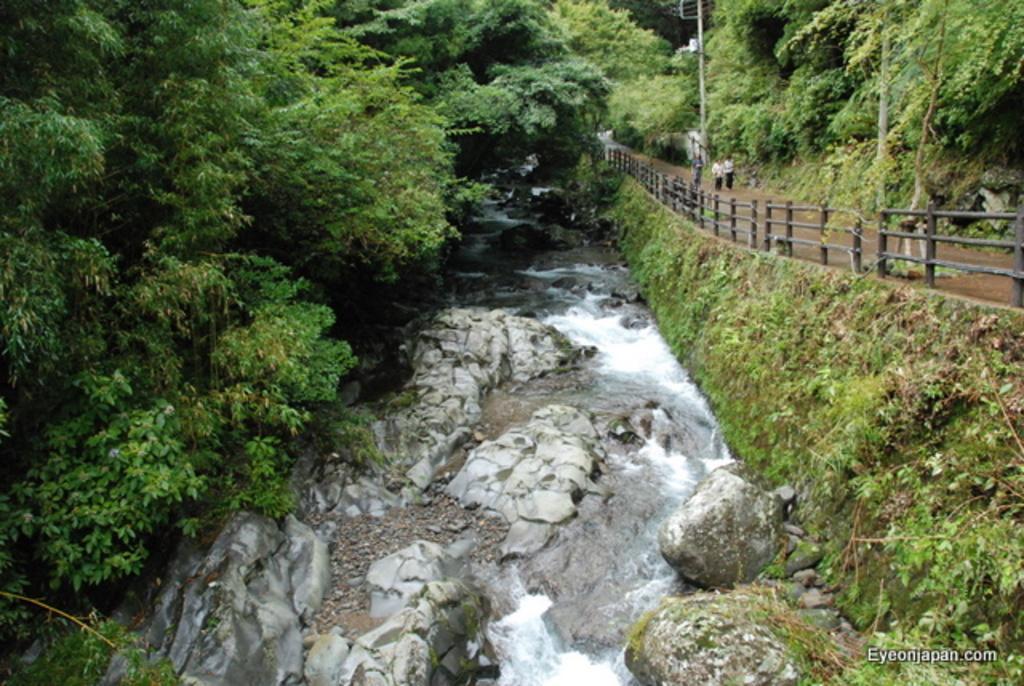Can you describe this image briefly? There is a river with rocks and water. On the left side there are trees. On the right side there is wall. Near to that there are railings. Also there is a road, pole and trees. Some people are on the road. 